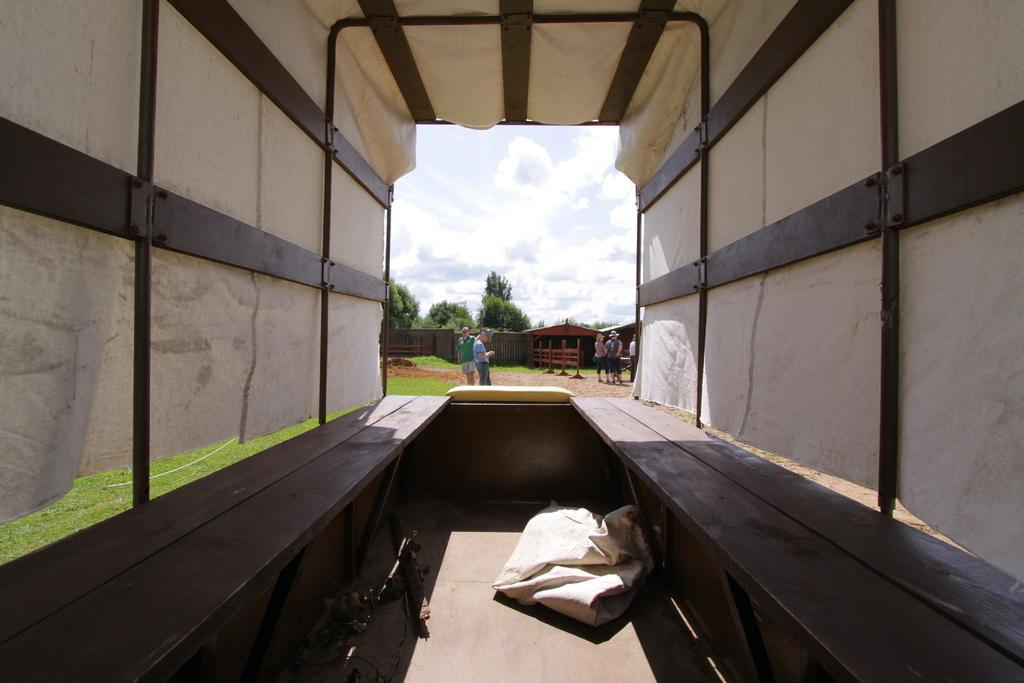What is the setting of the image? The image appears to depict the inside of a vehicle. Who or what can be seen inside the vehicle? There are people present in the vehicle. What can be seen outside the vehicle through a window or opening? Trees are visible through a window or opening in the vehicle. What is visible at the top of the image? The sky is visible at the top of the image. Who made the decision to create the hall in the image? There is no hall present in the image, so it is not possible to determine who made the decision to create it. 